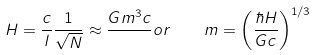Convert formula to latex. <formula><loc_0><loc_0><loc_500><loc_500>H = \frac { c } { l } \frac { 1 } { \sqrt { N } } \approx \frac { G m ^ { 3 } c } { } o r \quad m = \left ( \frac { \hbar { H } } { G c } \right ) ^ { 1 / 3 }</formula> 